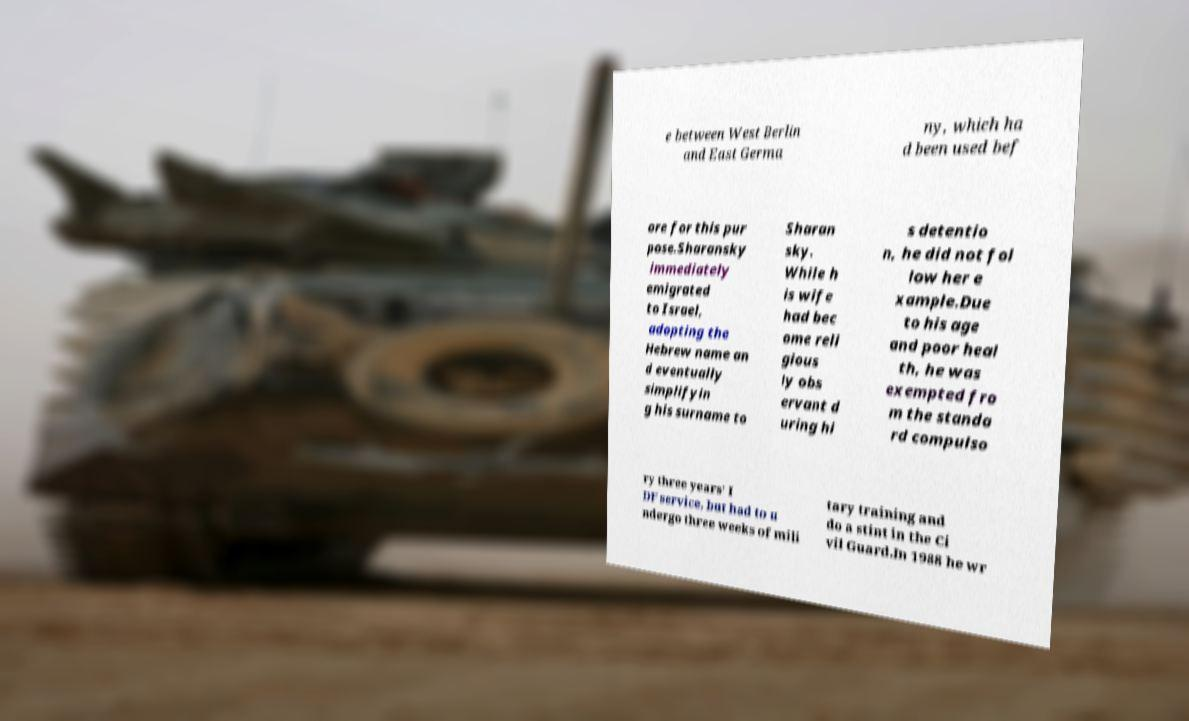Please read and relay the text visible in this image. What does it say? e between West Berlin and East Germa ny, which ha d been used bef ore for this pur pose.Sharansky immediately emigrated to Israel, adopting the Hebrew name an d eventually simplifyin g his surname to Sharan sky. While h is wife had bec ome reli gious ly obs ervant d uring hi s detentio n, he did not fol low her e xample.Due to his age and poor heal th, he was exempted fro m the standa rd compulso ry three years' I DF service, but had to u ndergo three weeks of mili tary training and do a stint in the Ci vil Guard.In 1988 he wr 